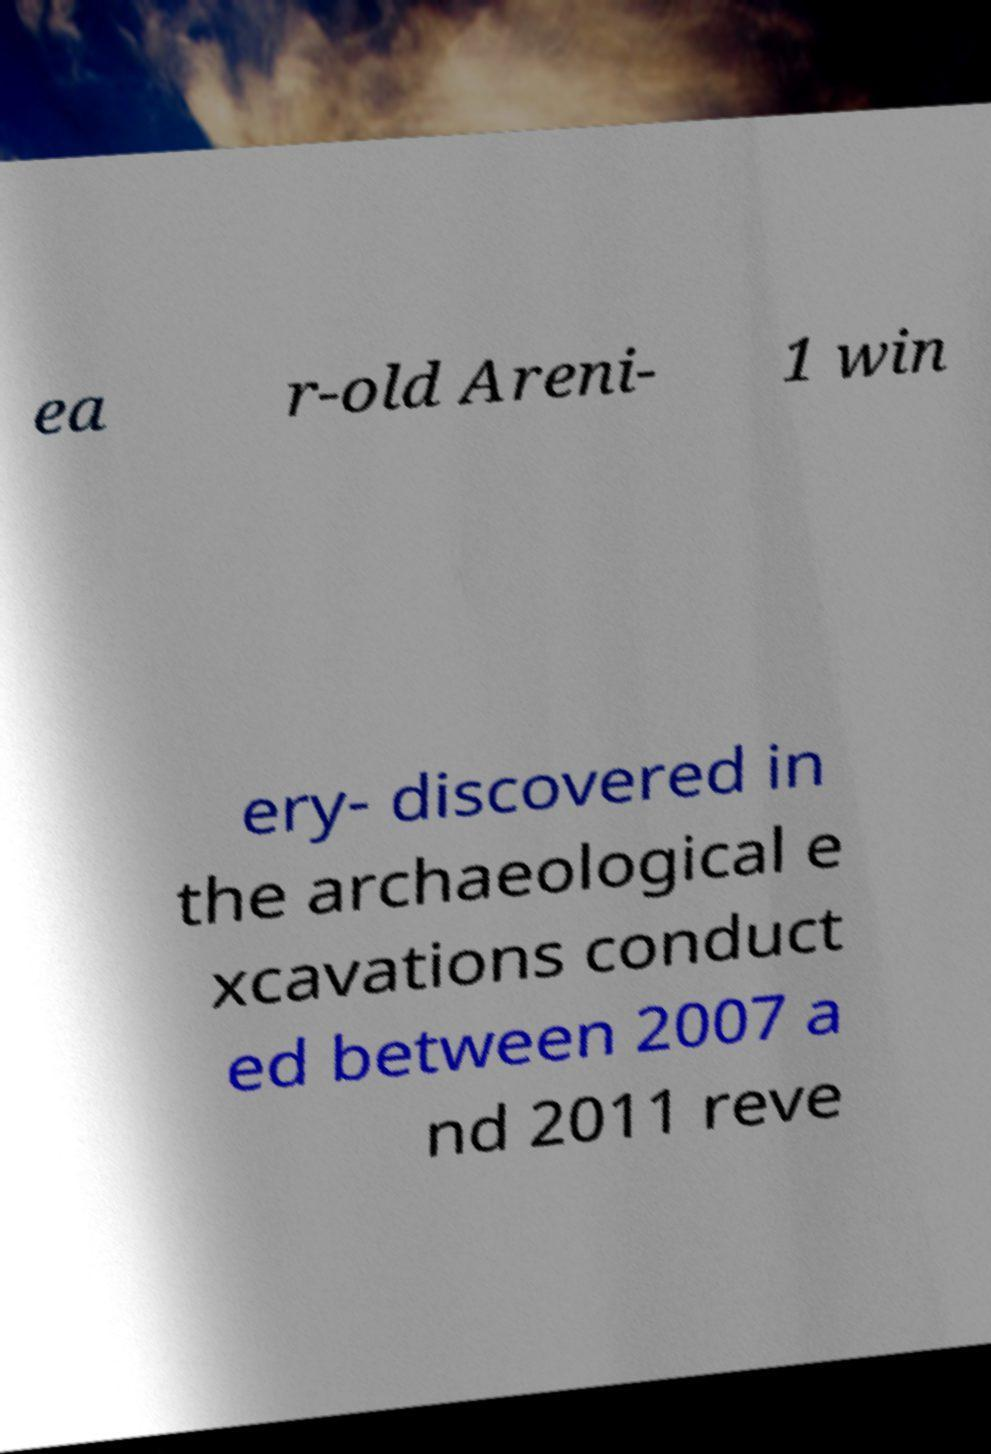There's text embedded in this image that I need extracted. Can you transcribe it verbatim? ea r-old Areni- 1 win ery- discovered in the archaeological e xcavations conduct ed between 2007 a nd 2011 reve 